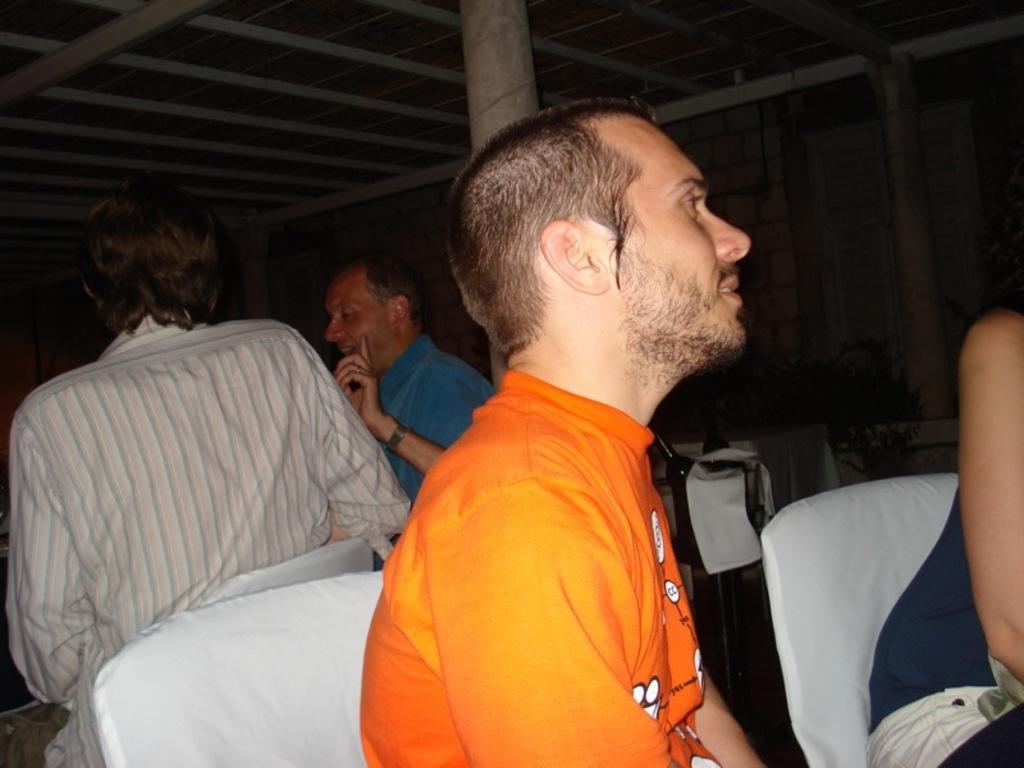What type of furniture is present in the image? There are chairs in the image. Are there any people in the image? Yes, there are people in the image. Can you describe the lighting in the image? The image is dark. What type of respect is shown by the people in the image? There is no indication of respect or any specific interaction between the people in the image, as it is not mentioned in the provided facts. 